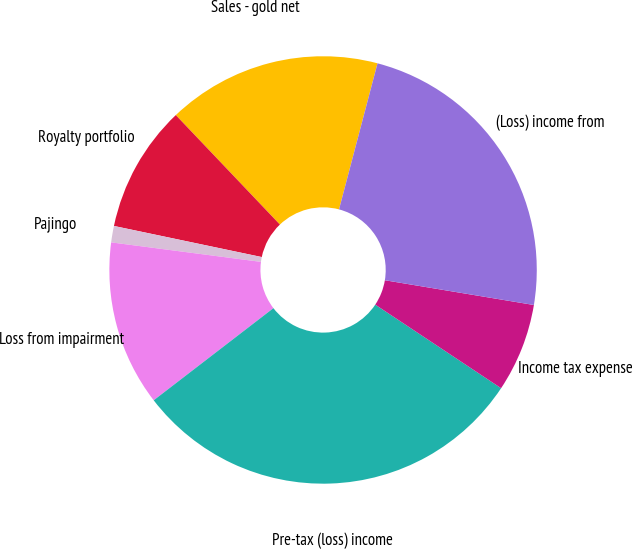Convert chart to OTSL. <chart><loc_0><loc_0><loc_500><loc_500><pie_chart><fcel>Sales - gold net<fcel>Royalty portfolio<fcel>Pajingo<fcel>Loss from impairment<fcel>Pre-tax (loss) income<fcel>Income tax expense<fcel>(Loss) income from<nl><fcel>16.2%<fcel>9.6%<fcel>1.24%<fcel>12.5%<fcel>30.23%<fcel>6.71%<fcel>23.52%<nl></chart> 